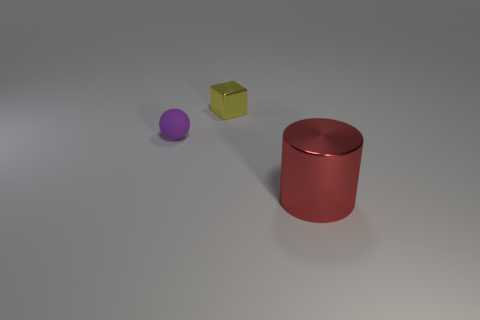Add 1 purple matte spheres. How many objects exist? 4 Subtract all cubes. How many objects are left? 2 Add 1 large gray matte cylinders. How many large gray matte cylinders exist? 1 Subtract 0 blue cylinders. How many objects are left? 3 Subtract all red metal things. Subtract all tiny purple rubber spheres. How many objects are left? 1 Add 1 small metal blocks. How many small metal blocks are left? 2 